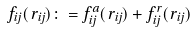Convert formula to latex. <formula><loc_0><loc_0><loc_500><loc_500>\vec { f } _ { i j } ( \vec { r } _ { i j } ) \colon = \vec { f } _ { i j } ^ { a } ( \vec { r } _ { i j } ) + \vec { f } _ { i j } ^ { r } ( \vec { r } _ { i j } )</formula> 